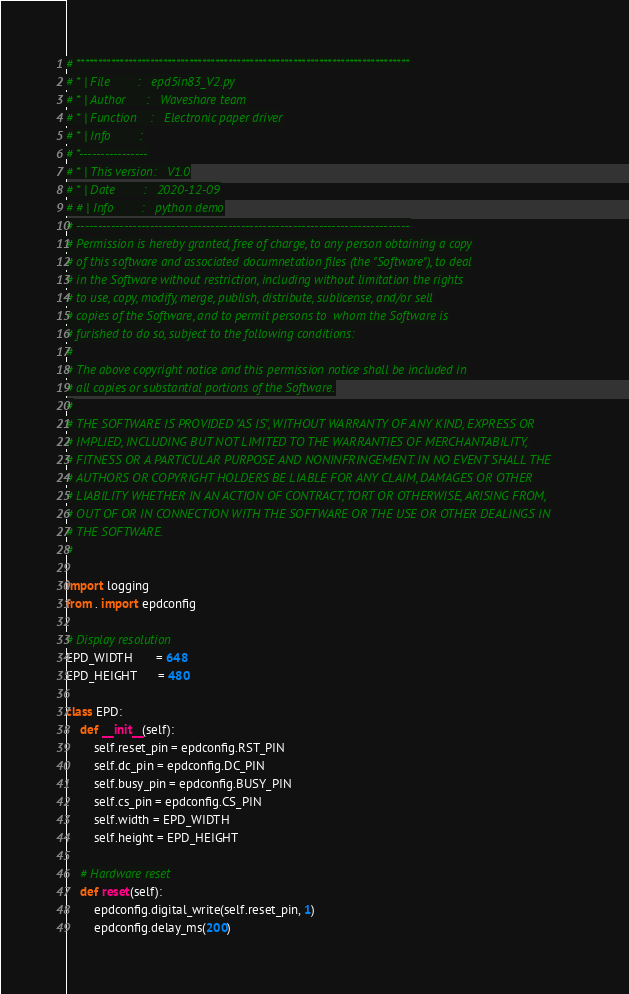Convert code to text. <code><loc_0><loc_0><loc_500><loc_500><_Python_># *****************************************************************************
# * | File        :	  epd5in83_V2.py
# * | Author      :   Waveshare team
# * | Function    :   Electronic paper driver
# * | Info        :
# *----------------
# * | This version:   V1.0
# * | Date        :   2020-12-09
# # | Info        :   python demo
# -----------------------------------------------------------------------------
# Permission is hereby granted, free of charge, to any person obtaining a copy
# of this software and associated documnetation files (the "Software"), to deal
# in the Software without restriction, including without limitation the rights
# to use, copy, modify, merge, publish, distribute, sublicense, and/or sell
# copies of the Software, and to permit persons to  whom the Software is
# furished to do so, subject to the following conditions:
#
# The above copyright notice and this permission notice shall be included in
# all copies or substantial portions of the Software.
#
# THE SOFTWARE IS PROVIDED "AS IS", WITHOUT WARRANTY OF ANY KIND, EXPRESS OR
# IMPLIED, INCLUDING BUT NOT LIMITED TO THE WARRANTIES OF MERCHANTABILITY,
# FITNESS OR A PARTICULAR PURPOSE AND NONINFRINGEMENT. IN NO EVENT SHALL THE
# AUTHORS OR COPYRIGHT HOLDERS BE LIABLE FOR ANY CLAIM, DAMAGES OR OTHER
# LIABILITY WHETHER IN AN ACTION OF CONTRACT, TORT OR OTHERWISE, ARISING FROM,
# OUT OF OR IN CONNECTION WITH THE SOFTWARE OR THE USE OR OTHER DEALINGS IN
# THE SOFTWARE.
#

import logging
from . import epdconfig

# Display resolution
EPD_WIDTH       = 648
EPD_HEIGHT      = 480

class EPD:
    def __init__(self):
        self.reset_pin = epdconfig.RST_PIN
        self.dc_pin = epdconfig.DC_PIN
        self.busy_pin = epdconfig.BUSY_PIN
        self.cs_pin = epdconfig.CS_PIN
        self.width = EPD_WIDTH
        self.height = EPD_HEIGHT
    
    # Hardware reset
    def reset(self):
        epdconfig.digital_write(self.reset_pin, 1)
        epdconfig.delay_ms(200) </code> 